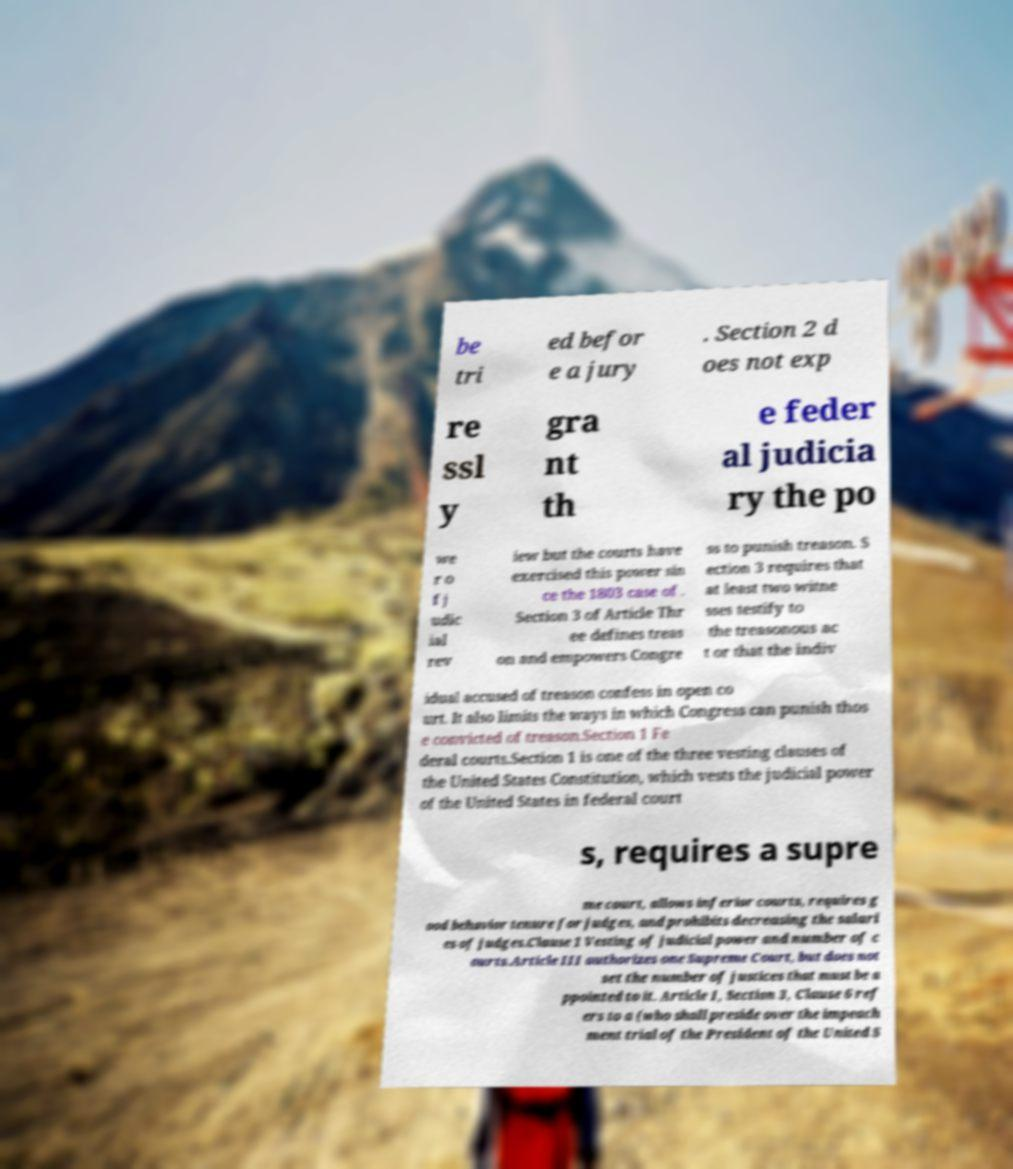Please read and relay the text visible in this image. What does it say? be tri ed befor e a jury . Section 2 d oes not exp re ssl y gra nt th e feder al judicia ry the po we r o f j udic ial rev iew but the courts have exercised this power sin ce the 1803 case of . Section 3 of Article Thr ee defines treas on and empowers Congre ss to punish treason. S ection 3 requires that at least two witne sses testify to the treasonous ac t or that the indiv idual accused of treason confess in open co urt. It also limits the ways in which Congress can punish thos e convicted of treason.Section 1 Fe deral courts.Section 1 is one of the three vesting clauses of the United States Constitution, which vests the judicial power of the United States in federal court s, requires a supre me court, allows inferior courts, requires g ood behavior tenure for judges, and prohibits decreasing the salari es of judges.Clause 1 Vesting of judicial power and number of c ourts.Article III authorizes one Supreme Court, but does not set the number of justices that must be a ppointed to it. Article I, Section 3, Clause 6 ref ers to a (who shall preside over the impeach ment trial of the President of the United S 